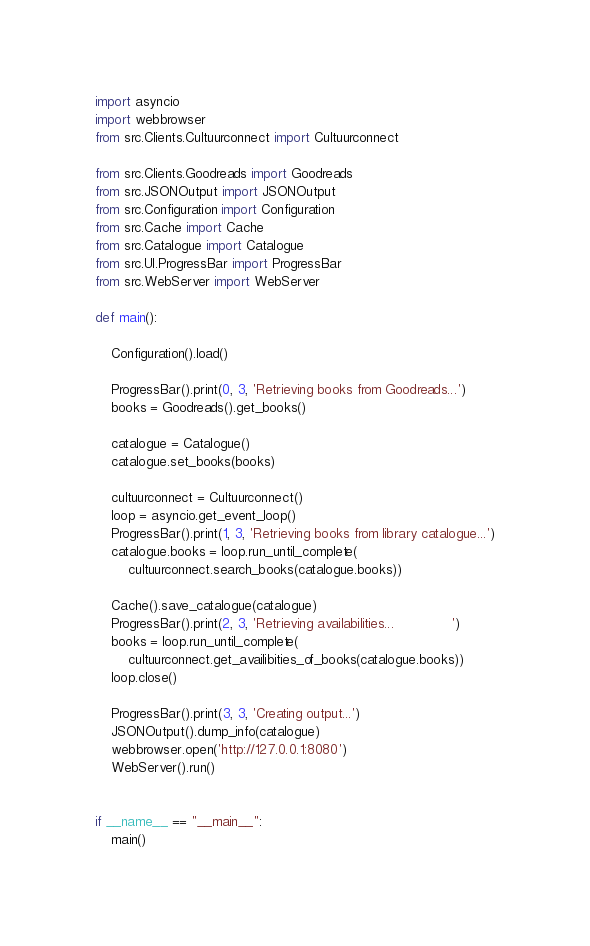<code> <loc_0><loc_0><loc_500><loc_500><_Python_>import asyncio
import webbrowser
from src.Clients.Cultuurconnect import Cultuurconnect

from src.Clients.Goodreads import Goodreads
from src.JSONOutput import JSONOutput
from src.Configuration import Configuration
from src.Cache import Cache
from src.Catalogue import Catalogue
from src.UI.ProgressBar import ProgressBar
from src.WebServer import WebServer

def main():

    Configuration().load()

    ProgressBar().print(0, 3, 'Retrieving books from Goodreads...')
    books = Goodreads().get_books()

    catalogue = Catalogue()
    catalogue.set_books(books)

    cultuurconnect = Cultuurconnect()
    loop = asyncio.get_event_loop()
    ProgressBar().print(1, 3, 'Retrieving books from library catalogue...')
    catalogue.books = loop.run_until_complete(
        cultuurconnect.search_books(catalogue.books))

    Cache().save_catalogue(catalogue)
    ProgressBar().print(2, 3, 'Retrieving availabilities...              ')
    books = loop.run_until_complete(
        cultuurconnect.get_availibities_of_books(catalogue.books))
    loop.close()

    ProgressBar().print(3, 3, 'Creating output...')
    JSONOutput().dump_info(catalogue)
    webbrowser.open('http://127.0.0.1:8080')
    WebServer().run()


if __name__ == "__main__":
    main()
</code> 